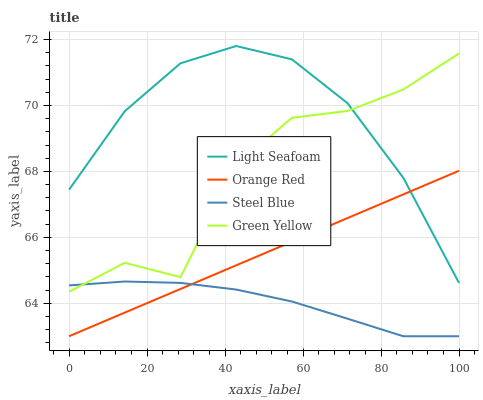Does Steel Blue have the minimum area under the curve?
Answer yes or no. Yes. Does Light Seafoam have the maximum area under the curve?
Answer yes or no. Yes. Does Orange Red have the minimum area under the curve?
Answer yes or no. No. Does Orange Red have the maximum area under the curve?
Answer yes or no. No. Is Orange Red the smoothest?
Answer yes or no. Yes. Is Green Yellow the roughest?
Answer yes or no. Yes. Is Light Seafoam the smoothest?
Answer yes or no. No. Is Light Seafoam the roughest?
Answer yes or no. No. Does Light Seafoam have the lowest value?
Answer yes or no. No. Does Light Seafoam have the highest value?
Answer yes or no. Yes. Does Orange Red have the highest value?
Answer yes or no. No. Is Steel Blue less than Light Seafoam?
Answer yes or no. Yes. Is Green Yellow greater than Orange Red?
Answer yes or no. Yes. Does Steel Blue intersect Green Yellow?
Answer yes or no. Yes. Is Steel Blue less than Green Yellow?
Answer yes or no. No. Is Steel Blue greater than Green Yellow?
Answer yes or no. No. Does Steel Blue intersect Light Seafoam?
Answer yes or no. No. 